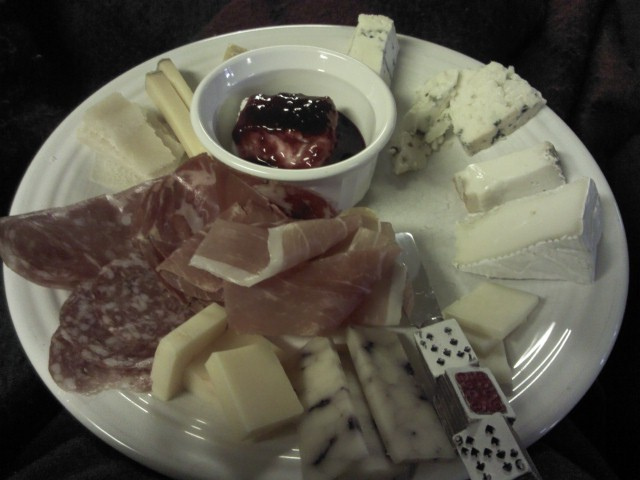What color is the back of the playing card printed cheese wedge? The back of the playing card printed cheese wedge appears to be red, based on the visible portion at the edge of the piece. Although the image does not show the entire back of the cheese wedge, the visible color suggests that the correct answer from the provided options would be A. red. 